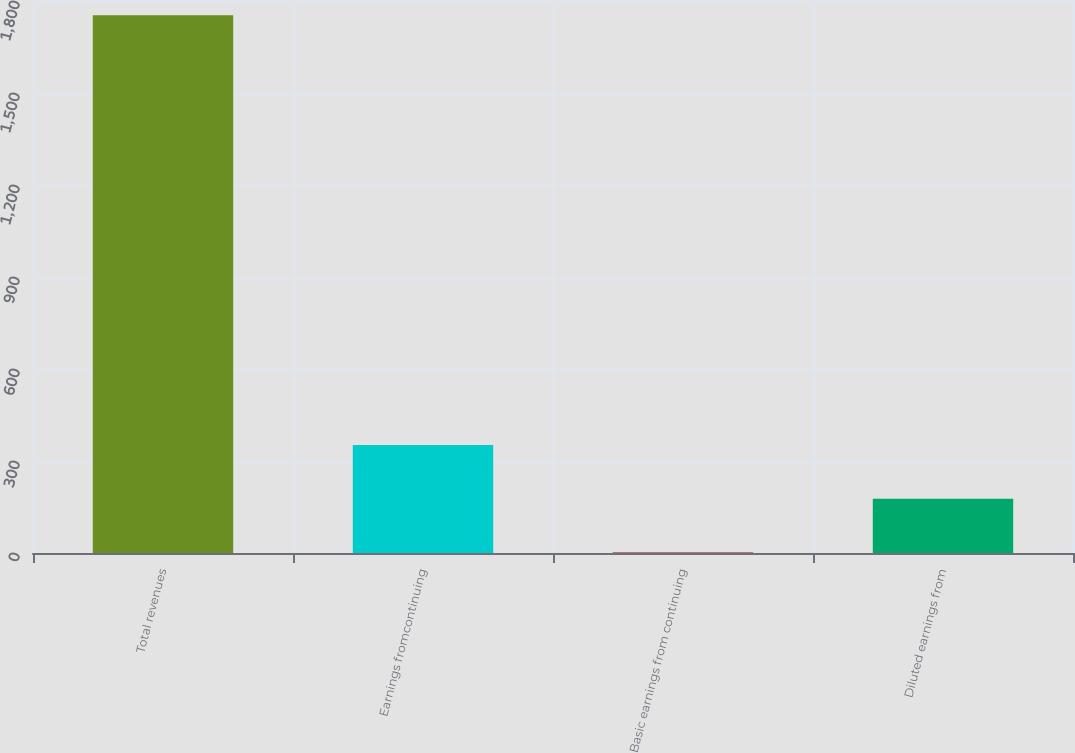<chart> <loc_0><loc_0><loc_500><loc_500><bar_chart><fcel>Total revenues<fcel>Earnings fromcontinuing<fcel>Basic earnings from continuing<fcel>Diluted earnings from<nl><fcel>1753.9<fcel>351.78<fcel>1.26<fcel>176.52<nl></chart> 